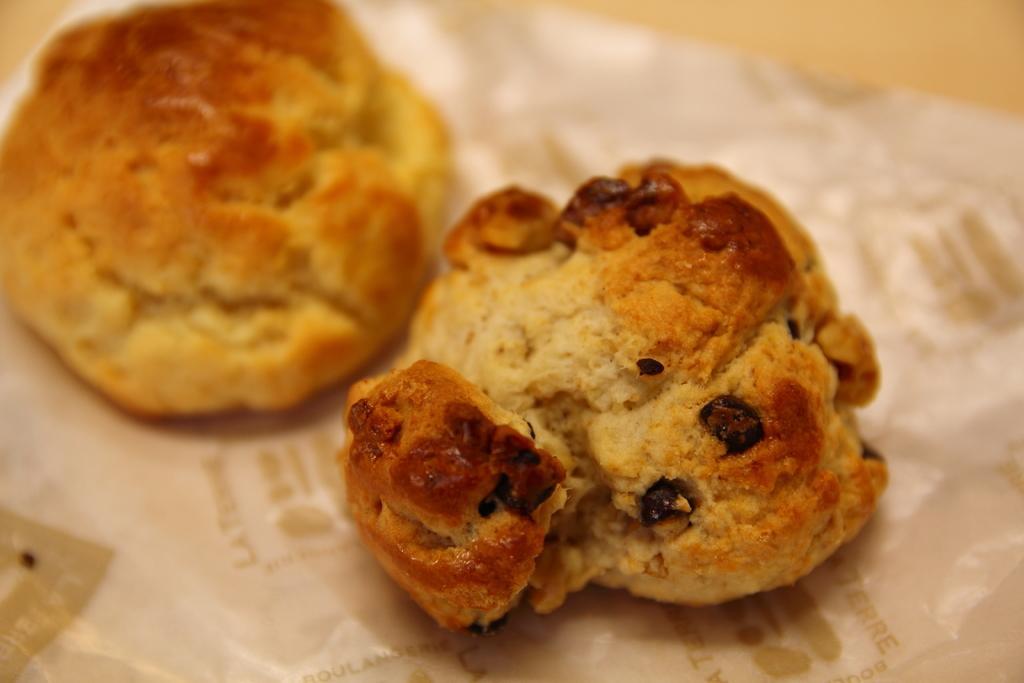Please provide a concise description of this image. In the center of the image we can see cookies placed on the table. 